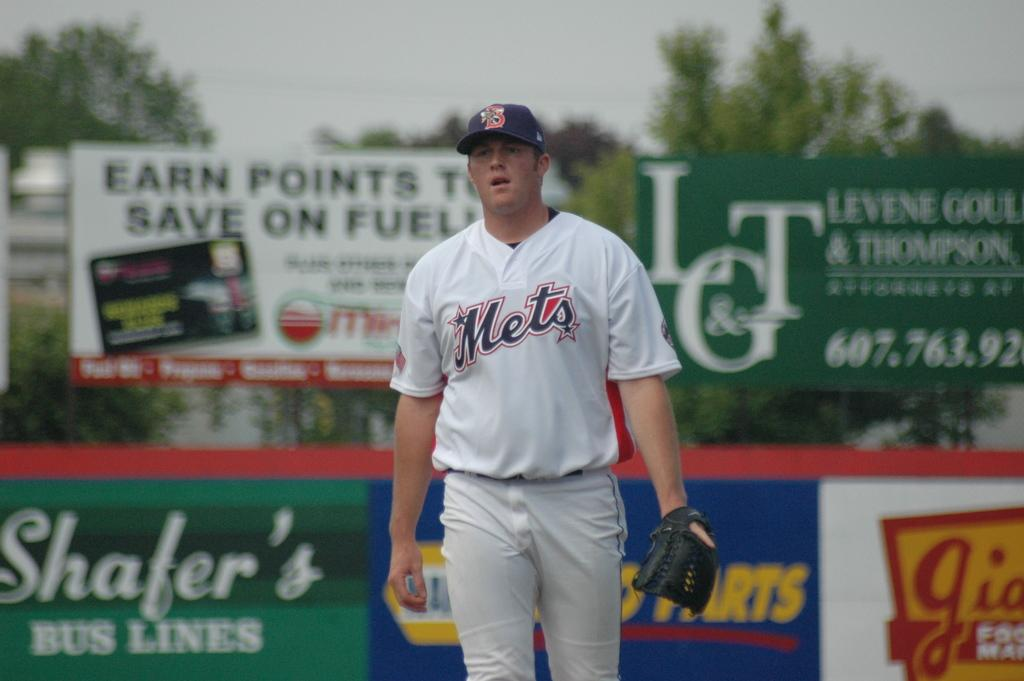<image>
Create a compact narrative representing the image presented. a person walking to the dugout with a Mets jersey on 